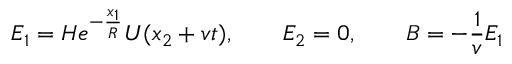Convert formula to latex. <formula><loc_0><loc_0><loc_500><loc_500>E _ { 1 } = H e ^ { - \frac { x _ { 1 } } { R } } U ( x _ { 2 } + v t ) , \quad E _ { 2 } = 0 , \quad B = - \frac { 1 } { v } E _ { 1 }</formula> 